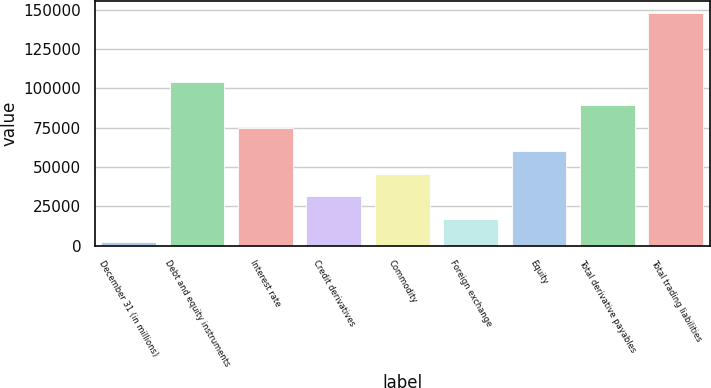<chart> <loc_0><loc_0><loc_500><loc_500><bar_chart><fcel>December 31 (in millions)<fcel>Debt and equity instruments<fcel>Interest rate<fcel>Credit derivatives<fcel>Commodity<fcel>Foreign exchange<fcel>Equity<fcel>Total derivative payables<fcel>Total trading liabilities<nl><fcel>2006<fcel>104172<fcel>74981.5<fcel>31196.2<fcel>45791.3<fcel>16601.1<fcel>60386.4<fcel>89576.6<fcel>147957<nl></chart> 